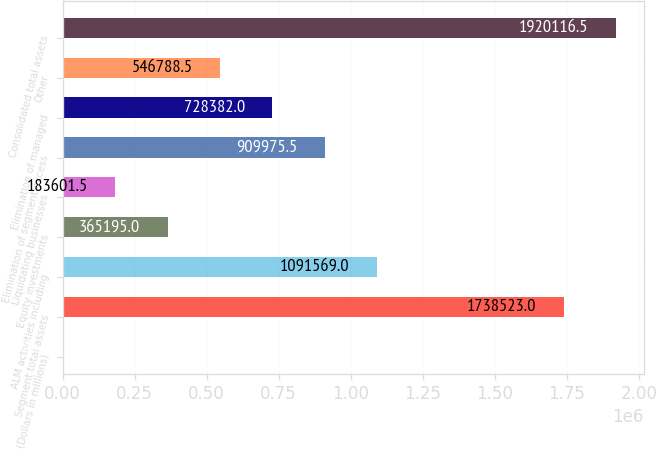Convert chart. <chart><loc_0><loc_0><loc_500><loc_500><bar_chart><fcel>(Dollars in millions)<fcel>Segment total assets<fcel>ALM activities including<fcel>Equity investments<fcel>Liquidating businesses<fcel>Elimination of segment excess<fcel>Elimination of managed<fcel>Other<fcel>Consolidated total assets<nl><fcel>2008<fcel>1.73852e+06<fcel>1.09157e+06<fcel>365195<fcel>183602<fcel>909976<fcel>728382<fcel>546788<fcel>1.92012e+06<nl></chart> 